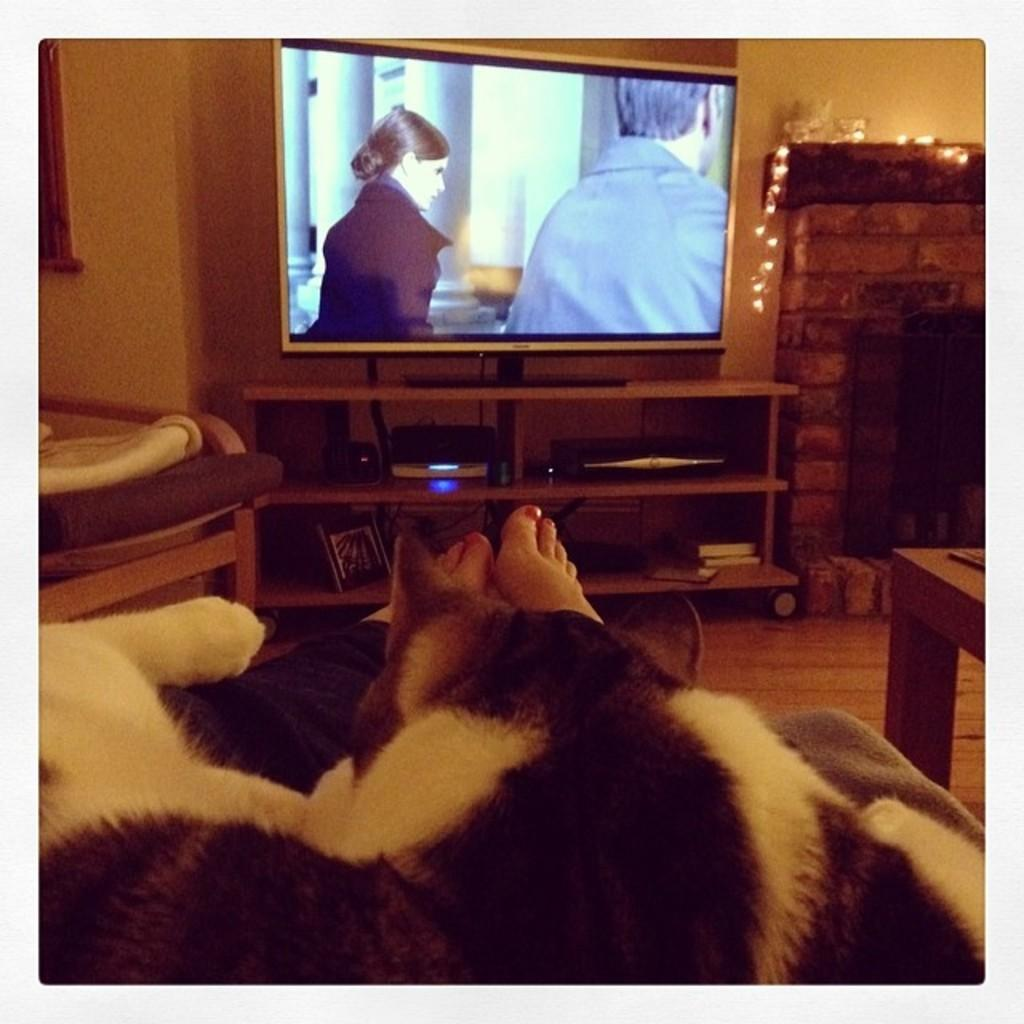What animal can be seen in the image? There is a cat in the image. What is the cat doing in the image? The cat is sleeping on a person's legs. What electronic device is present in the image? There is a TV in the image. What activity is being performed in front of the TV? There is a player in front of the TV. What type of storage for reading materials is visible in the image? There are books on a shelf. What architectural feature is present in the image? There is a firewood chimney tunnel in the image. What is the tax rate for the books on the shelf in the image? There is no information about tax rates in the image, as it focuses on the cat, the person's legs, the TV, the player, and the firewood chimney tunnel. 